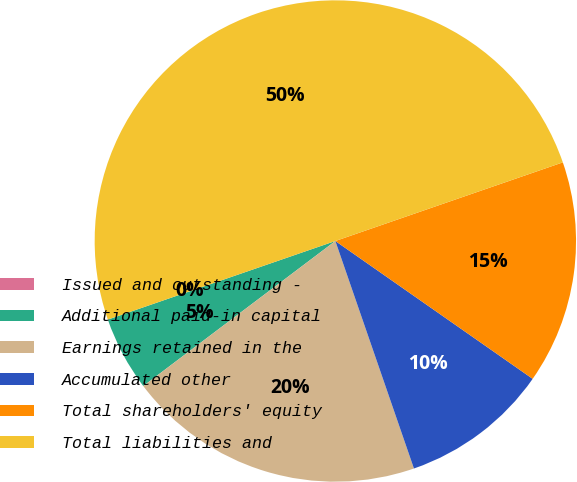Convert chart. <chart><loc_0><loc_0><loc_500><loc_500><pie_chart><fcel>Issued and outstanding -<fcel>Additional paid-in capital<fcel>Earnings retained in the<fcel>Accumulated other<fcel>Total shareholders' equity<fcel>Total liabilities and<nl><fcel>0.0%<fcel>5.0%<fcel>20.0%<fcel>10.0%<fcel>15.0%<fcel>49.99%<nl></chart> 